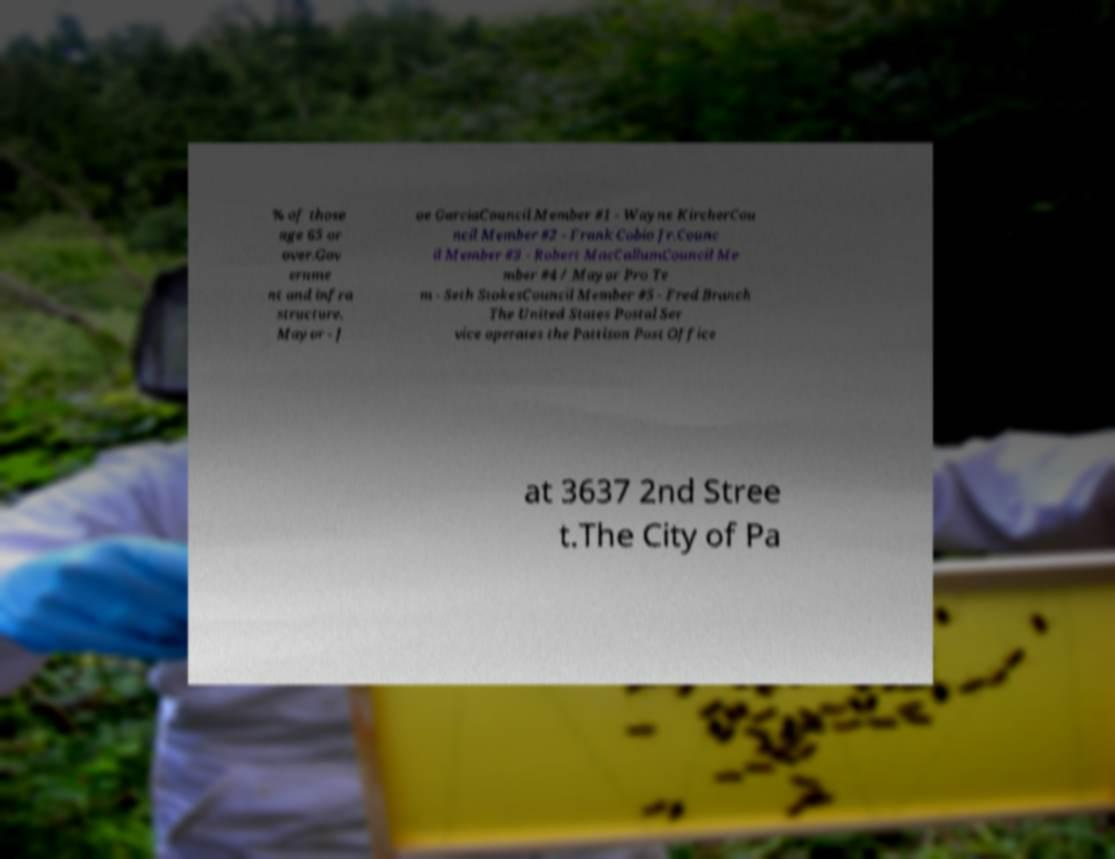I need the written content from this picture converted into text. Can you do that? % of those age 65 or over.Gov ernme nt and infra structure. Mayor - J oe GarciaCouncil Member #1 - Wayne KircherCou ncil Member #2 - Frank Cobio Jr.Counc il Member #3 - Robert MacCallumCouncil Me mber #4 / Mayor Pro Te m - Seth StokesCouncil Member #5 - Fred Branch The United States Postal Ser vice operates the Pattison Post Office at 3637 2nd Stree t.The City of Pa 